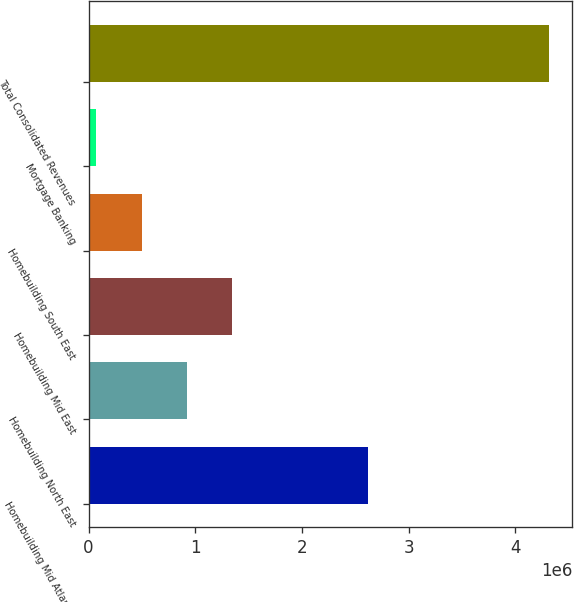Convert chart. <chart><loc_0><loc_0><loc_500><loc_500><bar_chart><fcel>Homebuilding Mid Atlantic<fcel>Homebuilding North East<fcel>Homebuilding Mid East<fcel>Homebuilding South East<fcel>Mortgage Banking<fcel>Total Consolidated Revenues<nl><fcel>2.62331e+06<fcel>921720<fcel>1.34647e+06<fcel>496969<fcel>72219<fcel>4.31972e+06<nl></chart> 